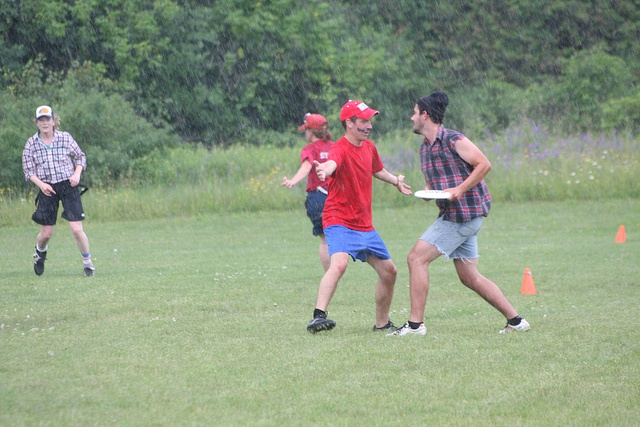Describe the objects in this image and their specific colors. I can see people in teal, lightpink, gray, and darkgray tones, people in teal, brown, salmon, lightblue, and darkgray tones, people in teal, darkgray, lavender, gray, and black tones, people in teal, brown, gray, and salmon tones, and frisbee in teal, white, darkgray, gray, and olive tones in this image. 